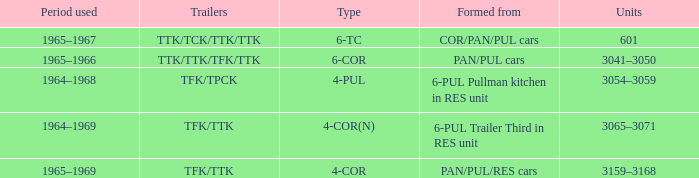Name the formed that has type of 4-cor PAN/PUL/RES cars. 